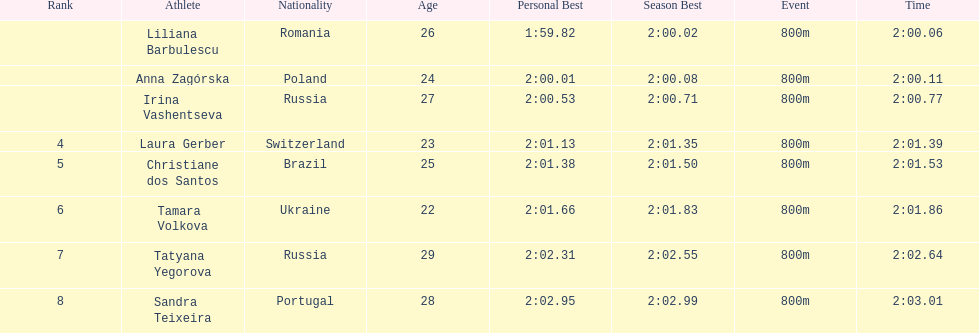Anna zagorska recieved 2nd place, what was her time? 2:00.11. 